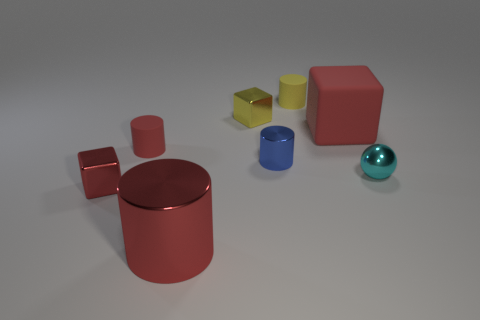Subtract all small metal cylinders. How many cylinders are left? 3 Subtract all brown cylinders. How many red cubes are left? 2 Subtract 1 cubes. How many cubes are left? 2 Subtract all blue cylinders. How many cylinders are left? 3 Add 1 blue shiny cylinders. How many objects exist? 9 Subtract all brown cylinders. Subtract all purple blocks. How many cylinders are left? 4 Subtract all balls. How many objects are left? 7 Subtract 0 green balls. How many objects are left? 8 Subtract all tiny cyan shiny balls. Subtract all tiny cyan metallic things. How many objects are left? 6 Add 3 tiny cyan objects. How many tiny cyan objects are left? 4 